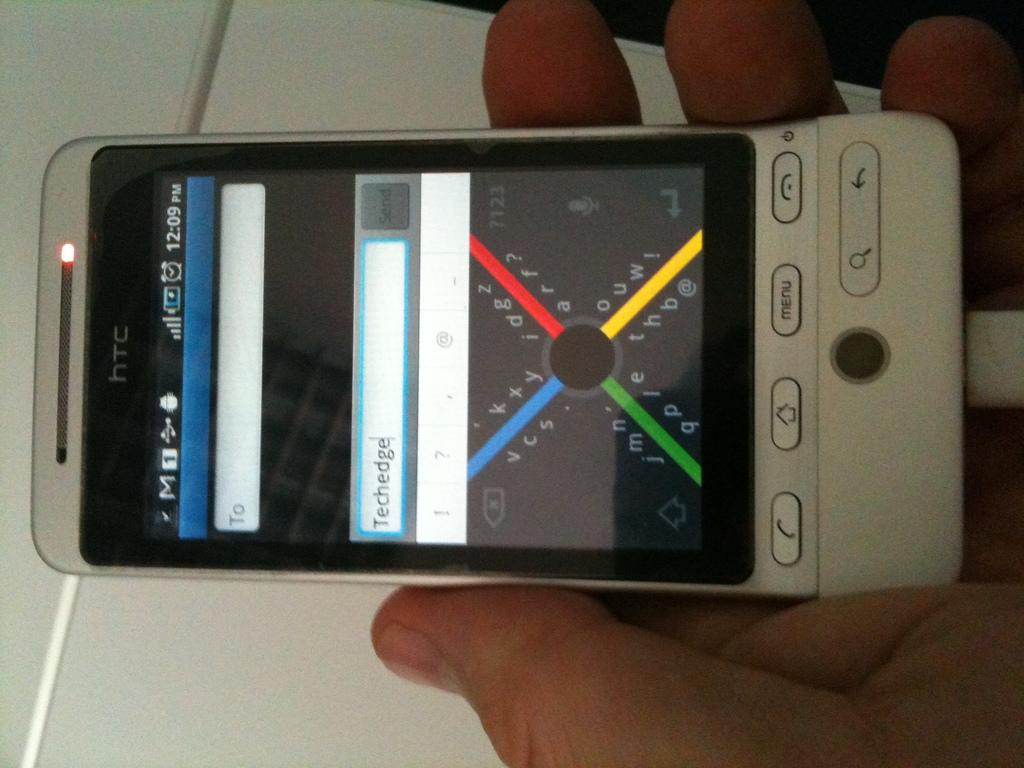What brand of smartphone is this?
Provide a succinct answer. Htc. Where is the menu button?
Ensure brevity in your answer.  To the right of the home button. 